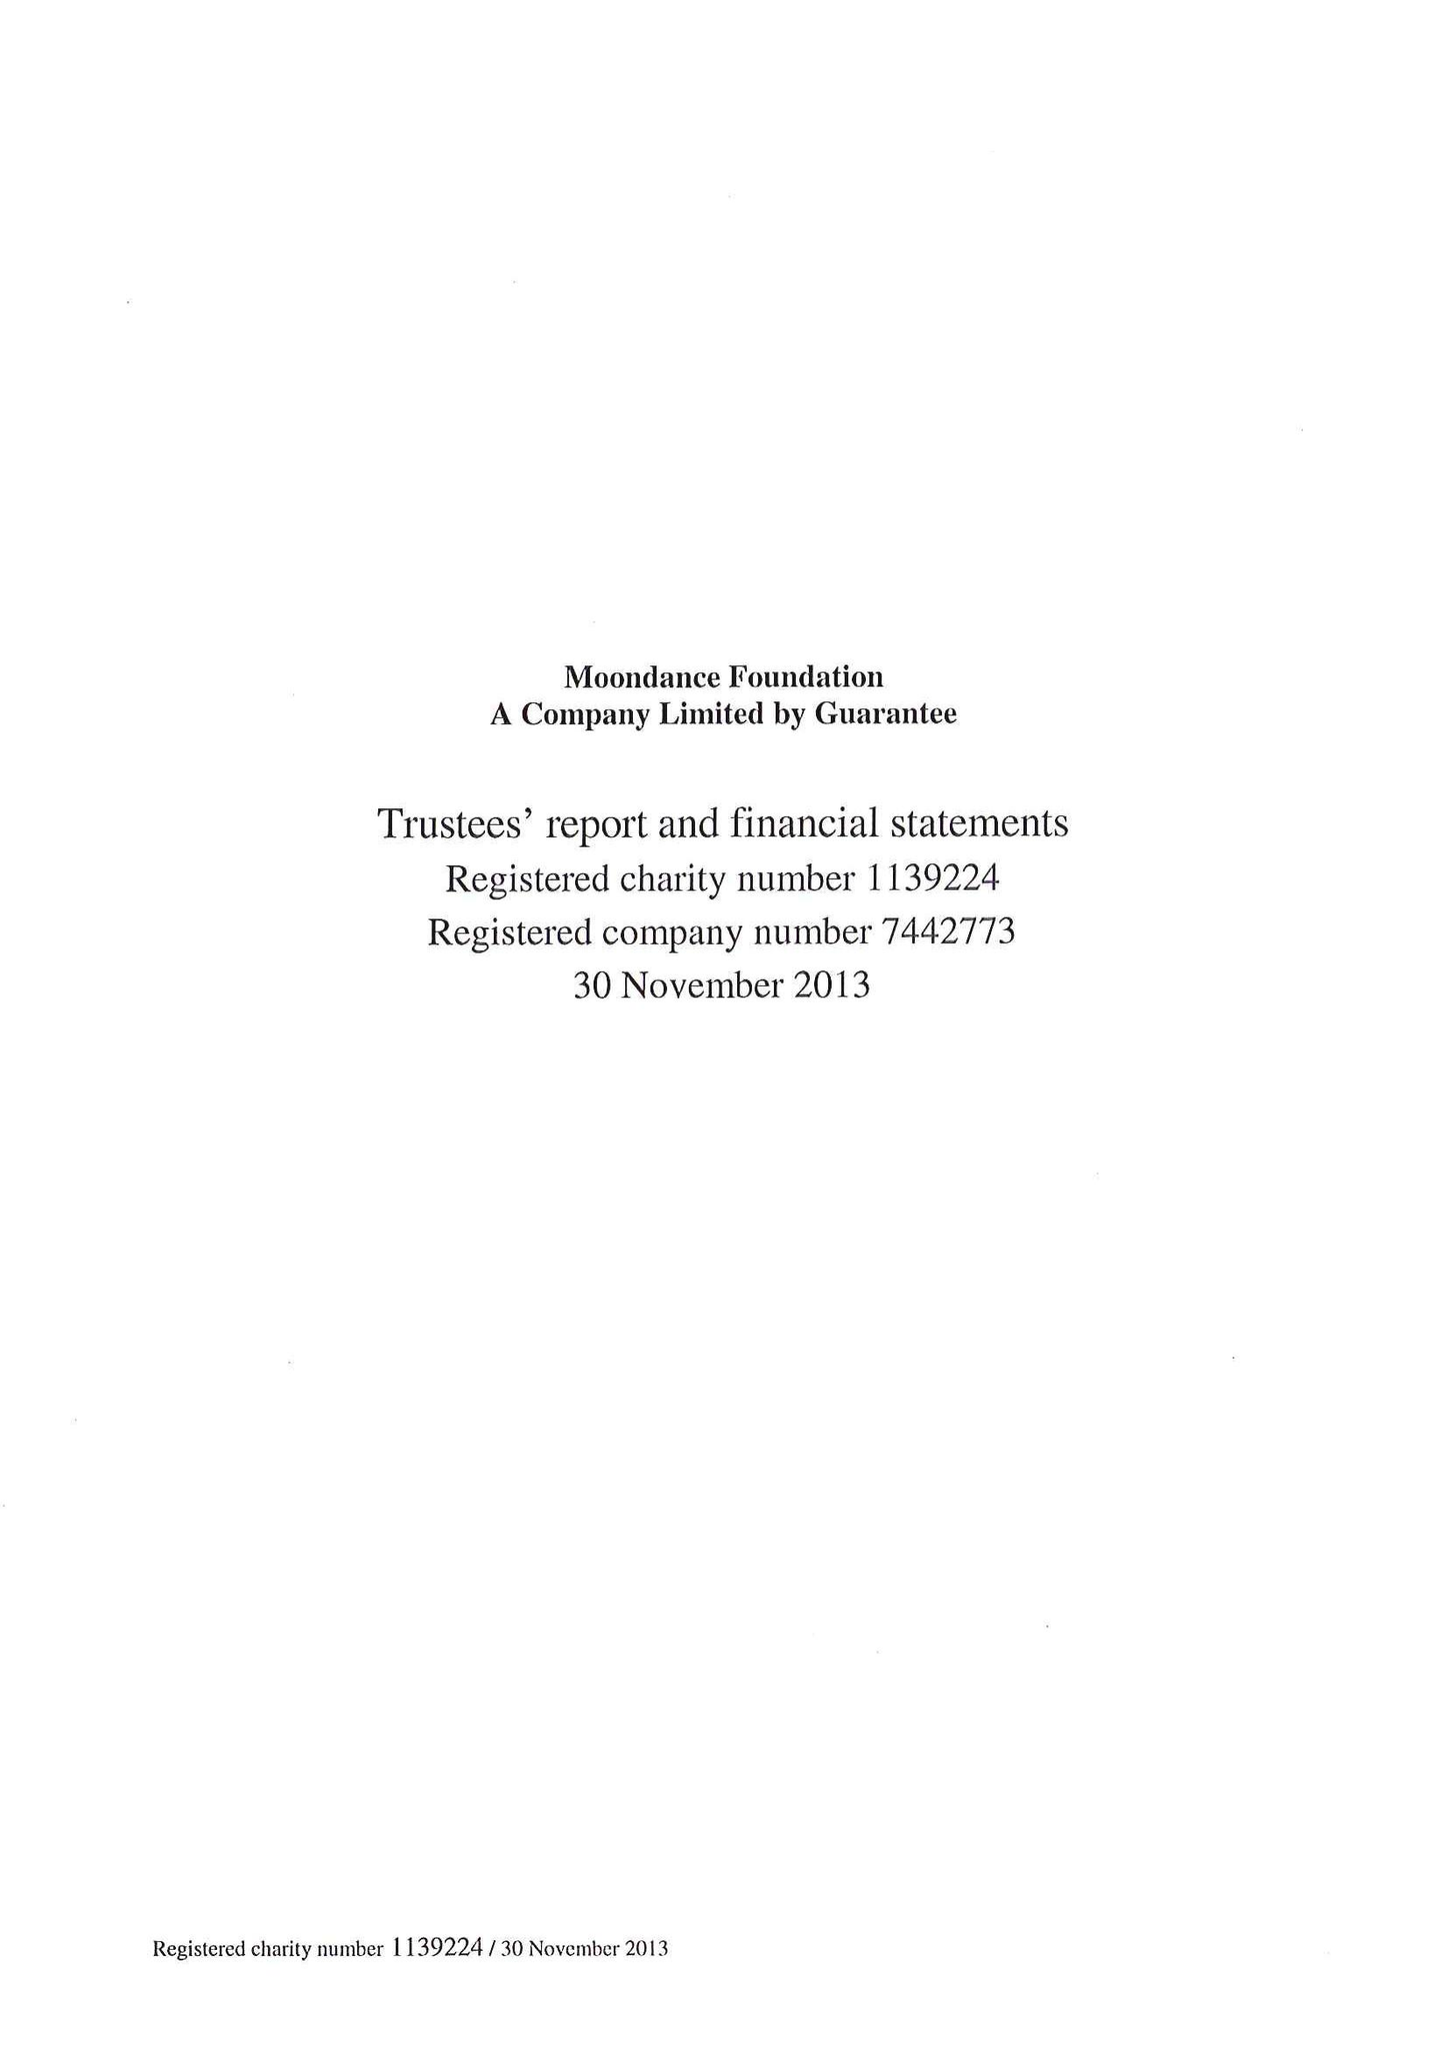What is the value for the income_annually_in_british_pounds?
Answer the question using a single word or phrase. 37421540.00 